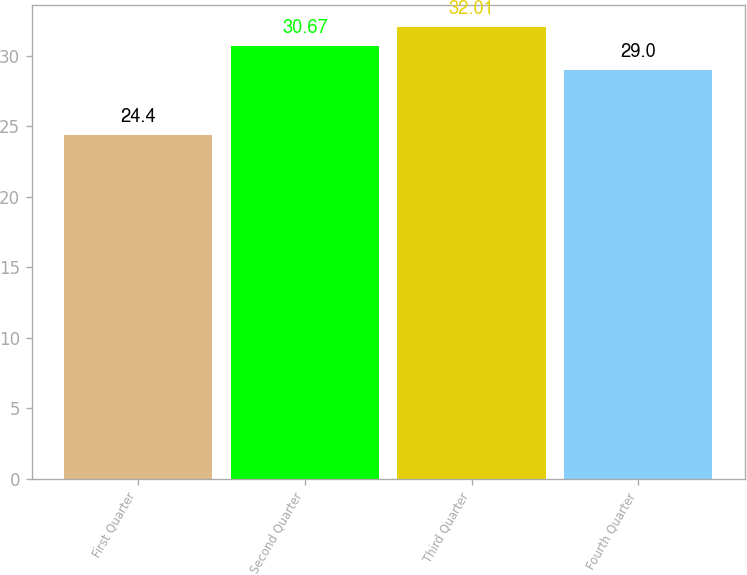<chart> <loc_0><loc_0><loc_500><loc_500><bar_chart><fcel>First Quarter<fcel>Second Quarter<fcel>Third Quarter<fcel>Fourth Quarter<nl><fcel>24.4<fcel>30.67<fcel>32.01<fcel>29<nl></chart> 